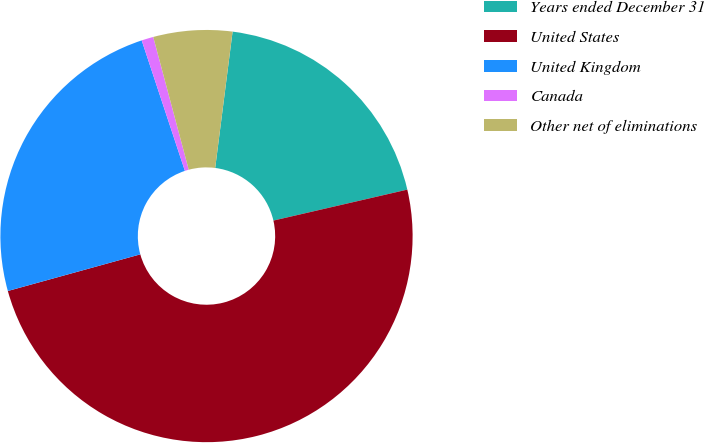Convert chart to OTSL. <chart><loc_0><loc_0><loc_500><loc_500><pie_chart><fcel>Years ended December 31<fcel>United States<fcel>United Kingdom<fcel>Canada<fcel>Other net of eliminations<nl><fcel>19.36%<fcel>49.32%<fcel>24.2%<fcel>0.93%<fcel>6.18%<nl></chart> 